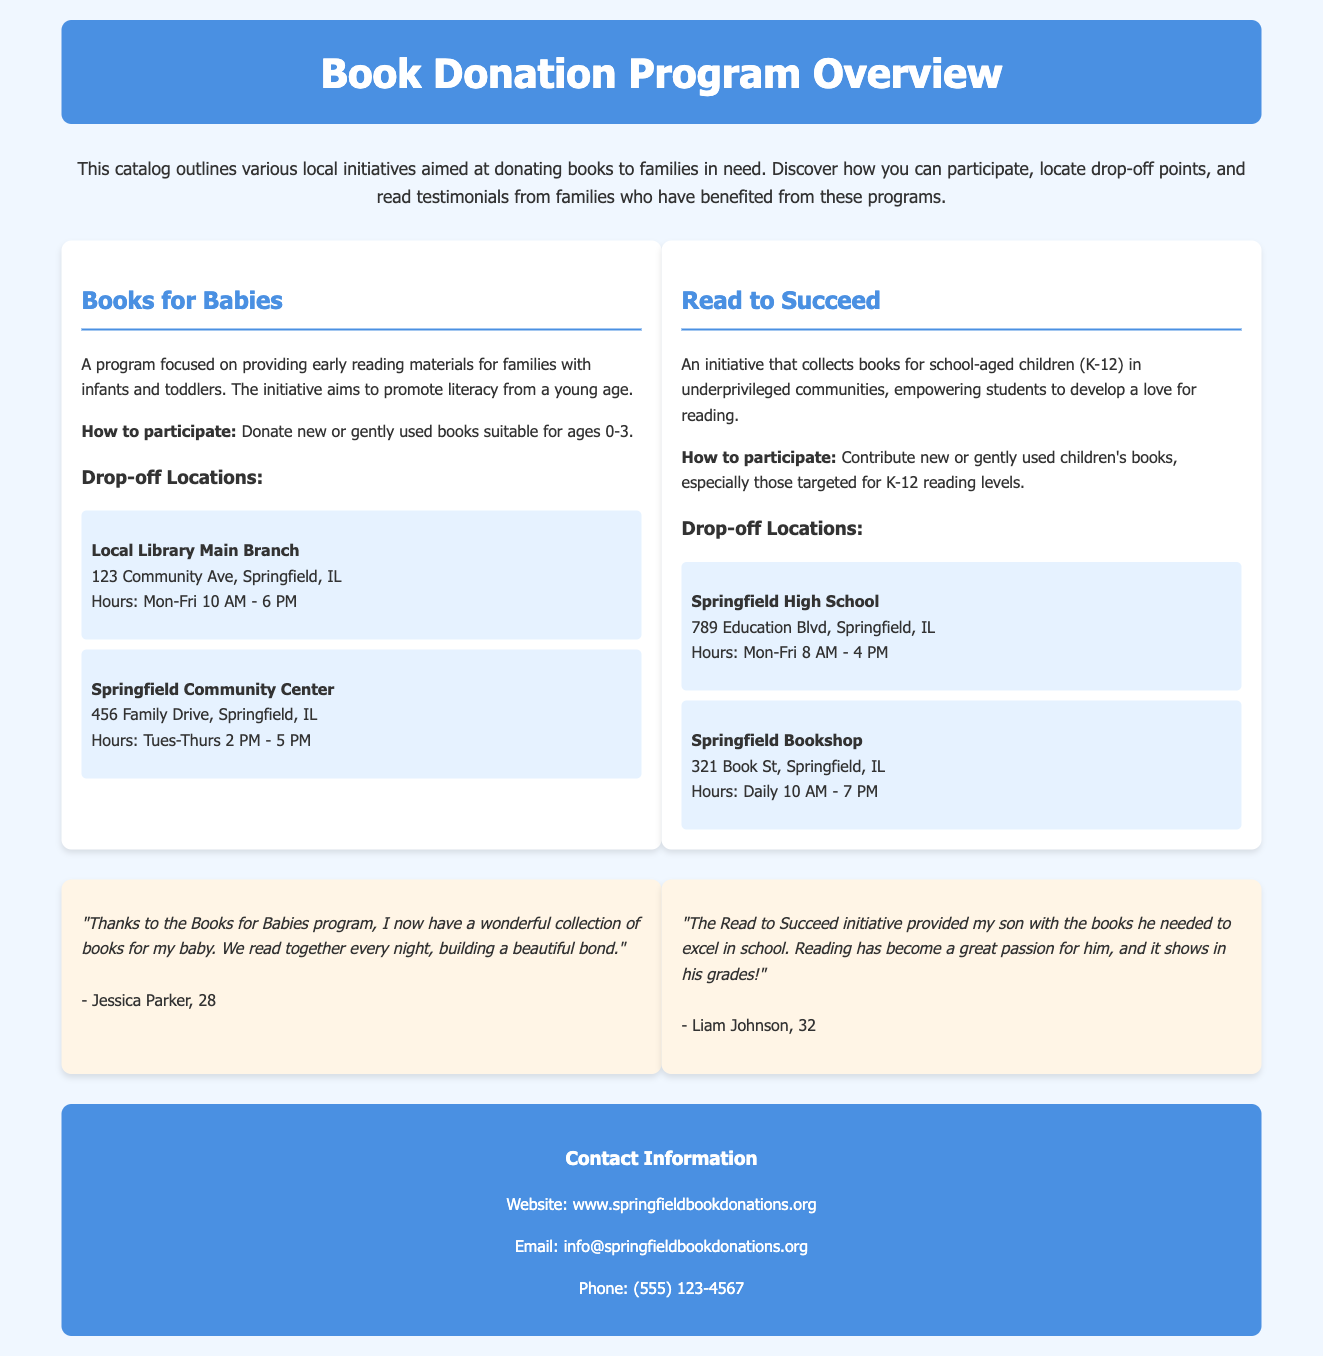what is the title of the document? The title is prominently displayed at the top of the document in the header section.
Answer: Book Donation Program Overview how many drop-off locations are listed for the Books for Babies program? This information can be found in the section about the Books for Babies program, where the drop-off locations are enumerated.
Answer: 2 what is one type of book the Read to Succeed initiative collects? The types of books collected are specified in the description of the Read to Succeed initiative.
Answer: Children's books who is a recipient of the Books for Babies program? The document contains testimonials from individuals who received benefits from the program, including their names.
Answer: Jessica Parker what is the contact phone number provided in the footer? The footer section includes the contact information, including a phone number.
Answer: (555) 123-4567 which program provides books for school-aged children? The specific program aimed at school-aged children is detailed in the document, with its name given.
Answer: Read to Succeed what are the hours for drop-off at Springfield High School? The operating hours for the drop-off location at Springfield High School are clearly stated in the drop-off section.
Answer: Mon-Fri 8 AM - 4 PM which program aims to promote literacy from a young age? The purpose of the programs is indicated in their introductory descriptions, specifying their target age groups.
Answer: Books for Babies 